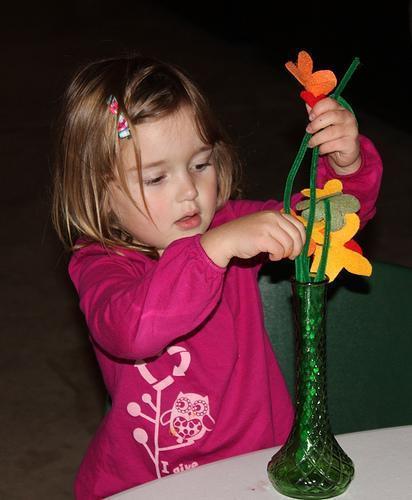How many dolls are in the image?
Give a very brief answer. 0. 